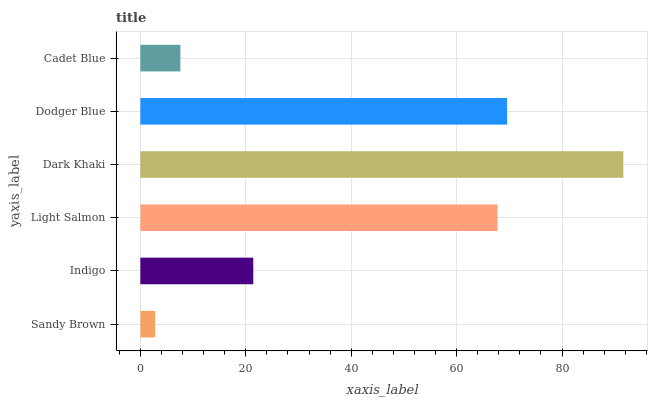Is Sandy Brown the minimum?
Answer yes or no. Yes. Is Dark Khaki the maximum?
Answer yes or no. Yes. Is Indigo the minimum?
Answer yes or no. No. Is Indigo the maximum?
Answer yes or no. No. Is Indigo greater than Sandy Brown?
Answer yes or no. Yes. Is Sandy Brown less than Indigo?
Answer yes or no. Yes. Is Sandy Brown greater than Indigo?
Answer yes or no. No. Is Indigo less than Sandy Brown?
Answer yes or no. No. Is Light Salmon the high median?
Answer yes or no. Yes. Is Indigo the low median?
Answer yes or no. Yes. Is Dark Khaki the high median?
Answer yes or no. No. Is Dark Khaki the low median?
Answer yes or no. No. 